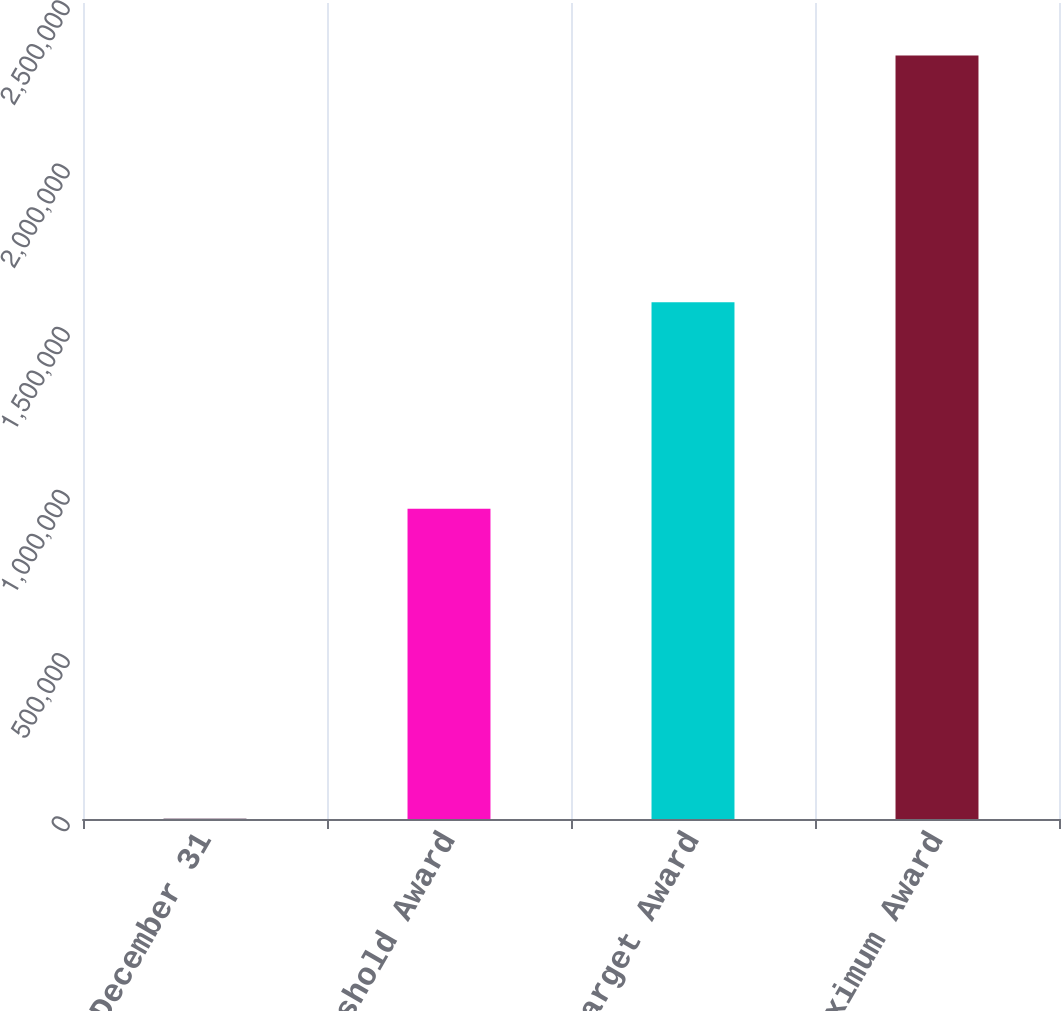Convert chart. <chart><loc_0><loc_0><loc_500><loc_500><bar_chart><fcel>December 31<fcel>Threshold Award<fcel>Target Award<fcel>Maximum Award<nl><fcel>2004<fcel>950837<fcel>1.58345e+06<fcel>2.33917e+06<nl></chart> 